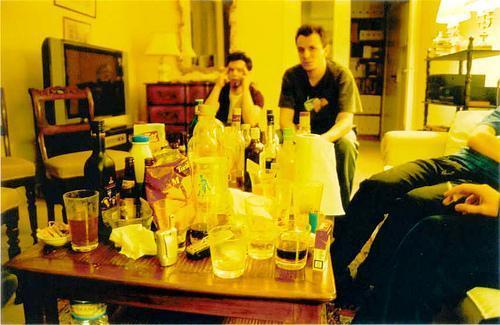How many people are shown holding cigarettes?
Give a very brief answer. 1. How many tvs are there?
Give a very brief answer. 1. How many bottles are visible?
Give a very brief answer. 2. How many people are in the picture?
Give a very brief answer. 4. How many donuts have vanilla frosting?
Give a very brief answer. 0. 